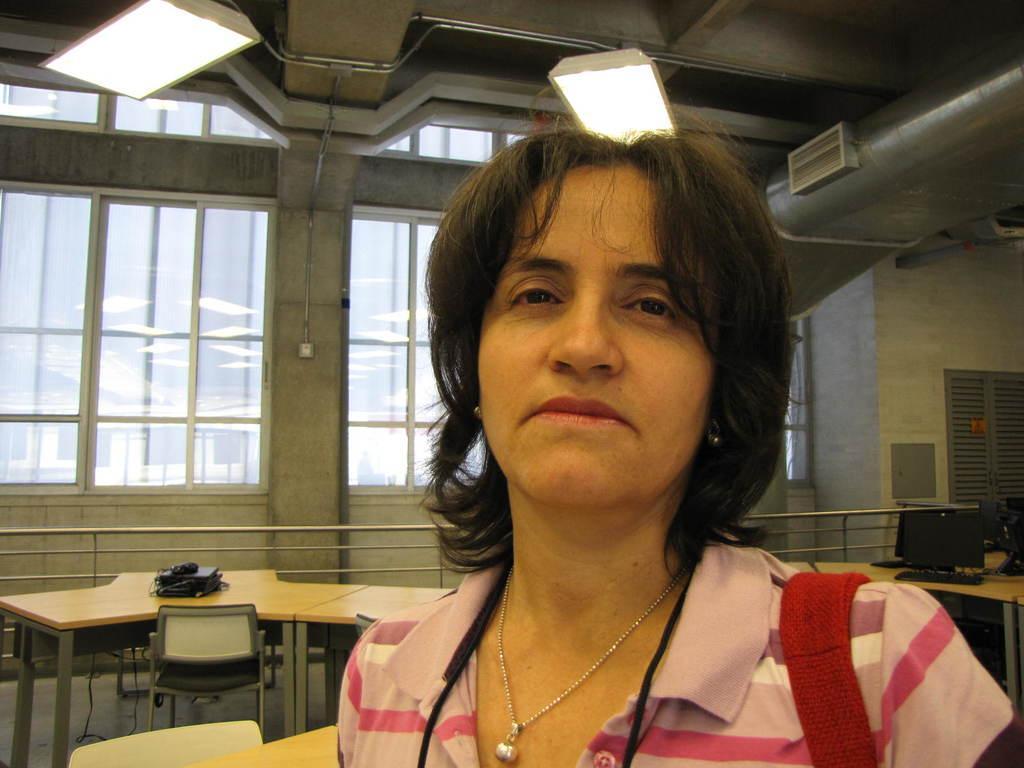Could you give a brief overview of what you see in this image? In the picture we can see a woman, background we can see a table, chair, windows and lights. 